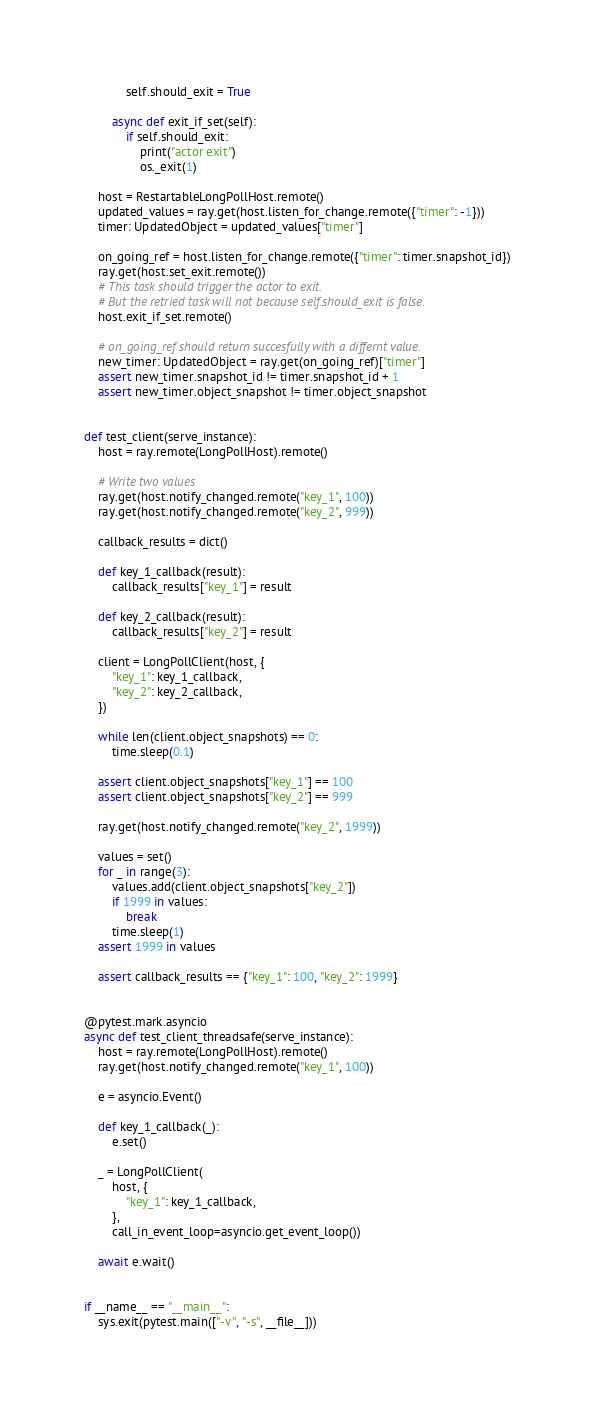<code> <loc_0><loc_0><loc_500><loc_500><_Python_>            self.should_exit = True

        async def exit_if_set(self):
            if self.should_exit:
                print("actor exit")
                os._exit(1)

    host = RestartableLongPollHost.remote()
    updated_values = ray.get(host.listen_for_change.remote({"timer": -1}))
    timer: UpdatedObject = updated_values["timer"]

    on_going_ref = host.listen_for_change.remote({"timer": timer.snapshot_id})
    ray.get(host.set_exit.remote())
    # This task should trigger the actor to exit.
    # But the retried task will not because self.should_exit is false.
    host.exit_if_set.remote()

    # on_going_ref should return succesfully with a differnt value.
    new_timer: UpdatedObject = ray.get(on_going_ref)["timer"]
    assert new_timer.snapshot_id != timer.snapshot_id + 1
    assert new_timer.object_snapshot != timer.object_snapshot


def test_client(serve_instance):
    host = ray.remote(LongPollHost).remote()

    # Write two values
    ray.get(host.notify_changed.remote("key_1", 100))
    ray.get(host.notify_changed.remote("key_2", 999))

    callback_results = dict()

    def key_1_callback(result):
        callback_results["key_1"] = result

    def key_2_callback(result):
        callback_results["key_2"] = result

    client = LongPollClient(host, {
        "key_1": key_1_callback,
        "key_2": key_2_callback,
    })

    while len(client.object_snapshots) == 0:
        time.sleep(0.1)

    assert client.object_snapshots["key_1"] == 100
    assert client.object_snapshots["key_2"] == 999

    ray.get(host.notify_changed.remote("key_2", 1999))

    values = set()
    for _ in range(3):
        values.add(client.object_snapshots["key_2"])
        if 1999 in values:
            break
        time.sleep(1)
    assert 1999 in values

    assert callback_results == {"key_1": 100, "key_2": 1999}


@pytest.mark.asyncio
async def test_client_threadsafe(serve_instance):
    host = ray.remote(LongPollHost).remote()
    ray.get(host.notify_changed.remote("key_1", 100))

    e = asyncio.Event()

    def key_1_callback(_):
        e.set()

    _ = LongPollClient(
        host, {
            "key_1": key_1_callback,
        },
        call_in_event_loop=asyncio.get_event_loop())

    await e.wait()


if __name__ == "__main__":
    sys.exit(pytest.main(["-v", "-s", __file__]))
</code> 